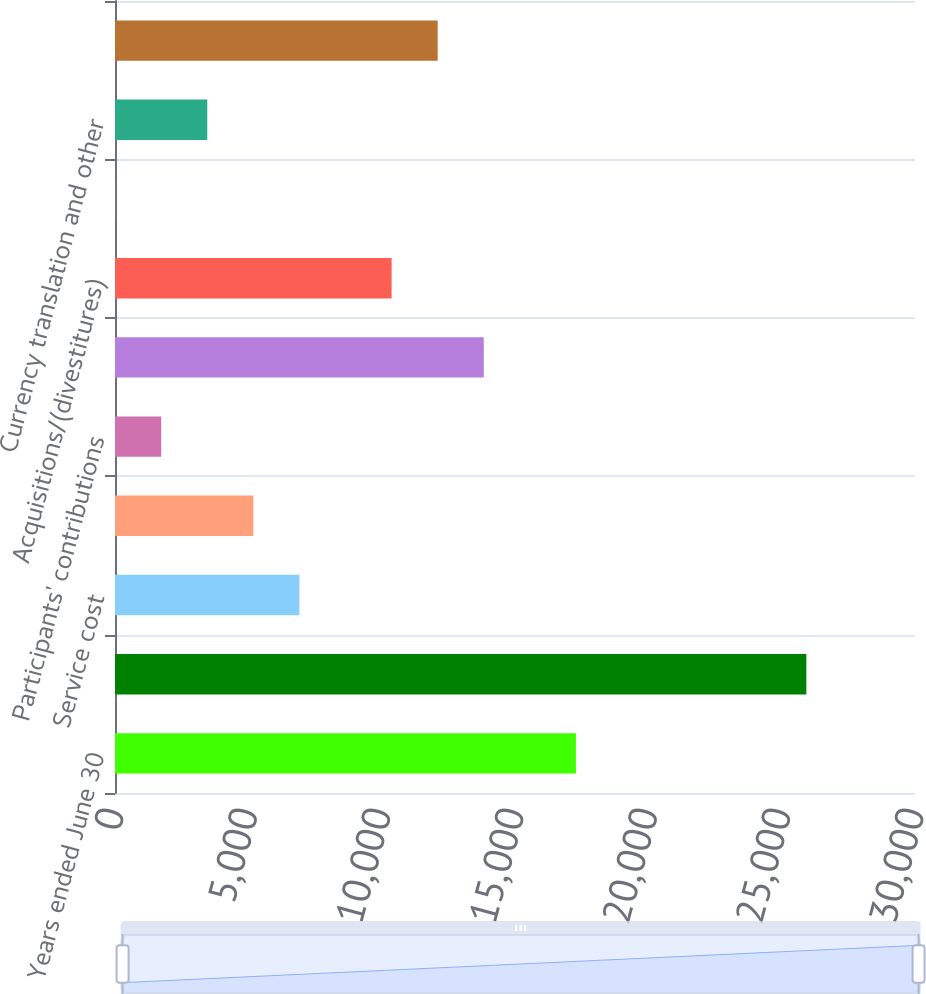Convert chart to OTSL. <chart><loc_0><loc_0><loc_500><loc_500><bar_chart><fcel>Years ended June 30<fcel>Benefit obligation at<fcel>Service cost<fcel>Interest cost<fcel>Participants' contributions<fcel>Net actuarial loss/(gain)<fcel>Acquisitions/(divestitures)<fcel>Special termination benefits<fcel>Currency translation and other<fcel>Benefit payments<nl><fcel>17285<fcel>25925.5<fcel>6916.4<fcel>5188.3<fcel>1732.1<fcel>13828.8<fcel>10372.6<fcel>4<fcel>3460.2<fcel>12100.7<nl></chart> 